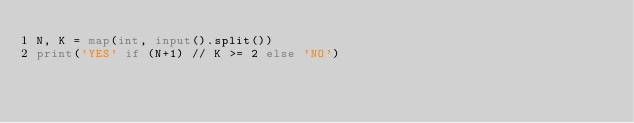Convert code to text. <code><loc_0><loc_0><loc_500><loc_500><_Python_>N, K = map(int, input().split())
print('YES' if (N+1) // K >= 2 else 'NO')</code> 